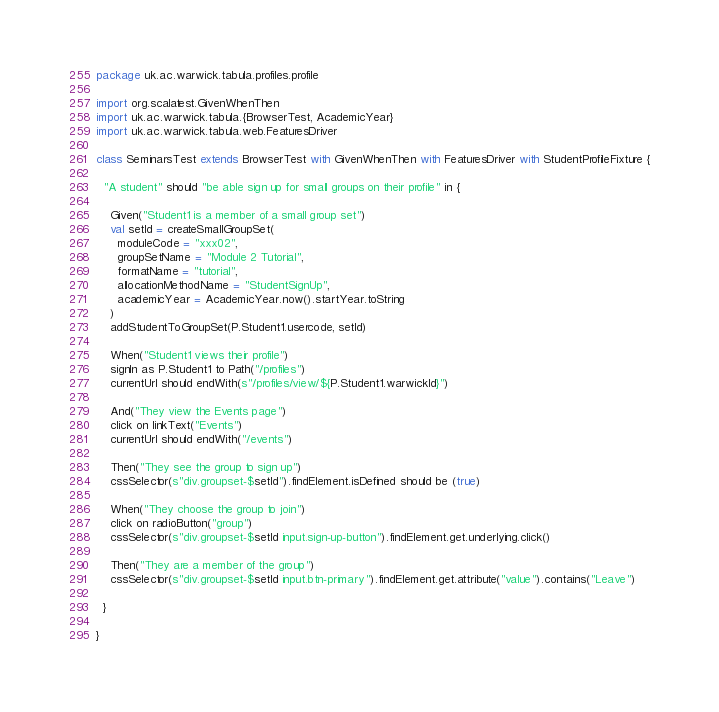Convert code to text. <code><loc_0><loc_0><loc_500><loc_500><_Scala_>package uk.ac.warwick.tabula.profiles.profile

import org.scalatest.GivenWhenThen
import uk.ac.warwick.tabula.{BrowserTest, AcademicYear}
import uk.ac.warwick.tabula.web.FeaturesDriver

class SeminarsTest extends BrowserTest with GivenWhenThen with FeaturesDriver with StudentProfileFixture {

  "A student" should "be able sign up for small groups on their profile" in {

    Given("Student1 is a member of a small group set")
    val setId = createSmallGroupSet(
      moduleCode = "xxx02",
      groupSetName = "Module 2 Tutorial",
      formatName = "tutorial",
      allocationMethodName = "StudentSignUp",
      academicYear = AcademicYear.now().startYear.toString
    )
    addStudentToGroupSet(P.Student1.usercode, setId)

    When("Student1 views their profile")
    signIn as P.Student1 to Path("/profiles")
    currentUrl should endWith(s"/profiles/view/${P.Student1.warwickId}")

    And("They view the Events page")
    click on linkText("Events")
    currentUrl should endWith("/events")

    Then("They see the group to sign up")
    cssSelector(s"div.groupset-$setId").findElement.isDefined should be (true)

    When("They choose the group to join")
    click on radioButton("group")
    cssSelector(s"div.groupset-$setId input.sign-up-button").findElement.get.underlying.click()

    Then("They are a member of the group")
    cssSelector(s"div.groupset-$setId input.btn-primary").findElement.get.attribute("value").contains("Leave")

  }

}
</code> 